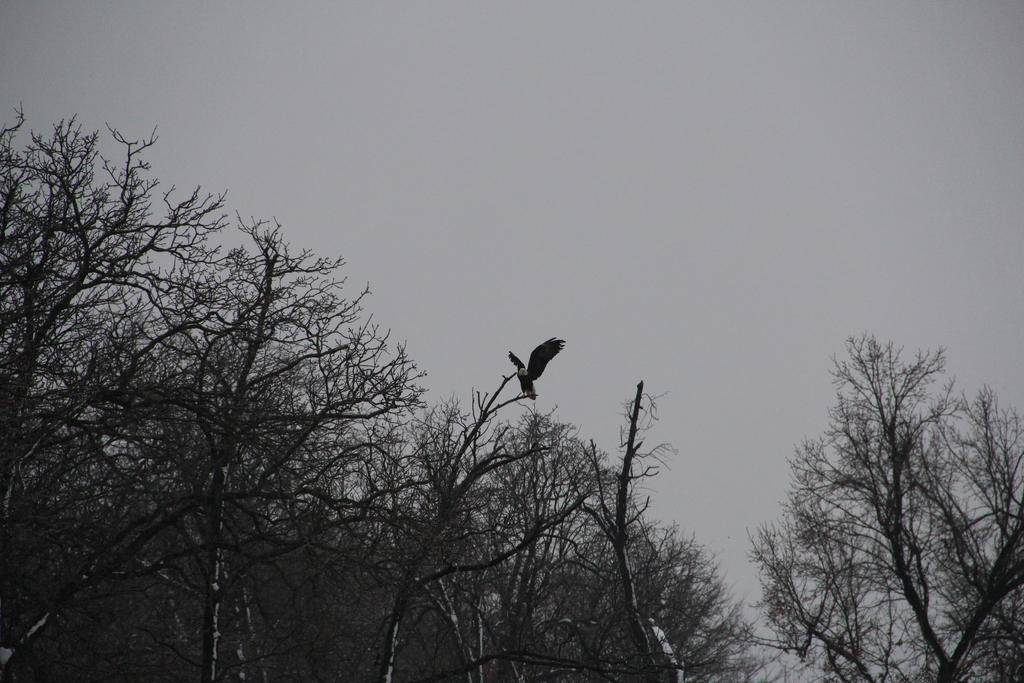What type of animal can be seen in the image? There is a bird in the image. Where is the bird located in the image? The bird is on a branch. What type of vegetation is visible in the image? There are trees in the image. What is visible in the background of the image? The sky is visible in the background of the image. How does the bird increase its brain capacity in the image? There is no indication in the image that the bird is increasing its brain capacity. 